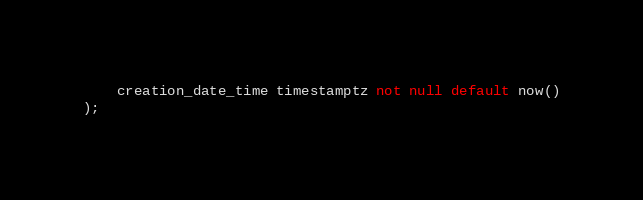<code> <loc_0><loc_0><loc_500><loc_500><_SQL_>	creation_date_time timestamptz not null default now()
);
</code> 